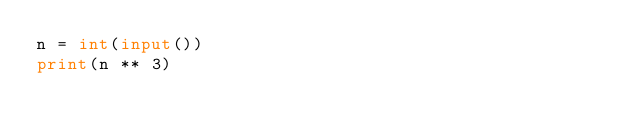<code> <loc_0><loc_0><loc_500><loc_500><_Python_>n = int(input())
print(n ** 3)</code> 